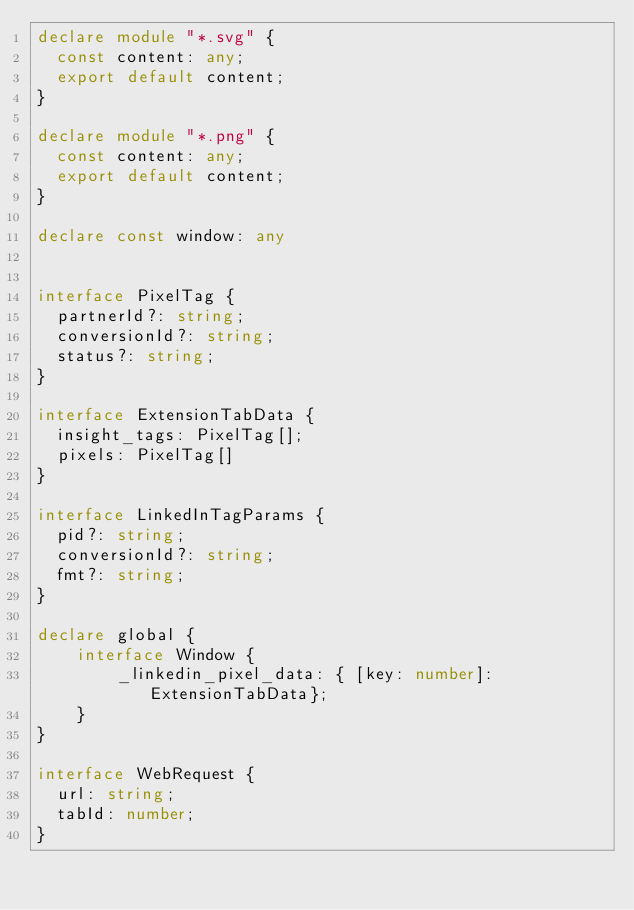<code> <loc_0><loc_0><loc_500><loc_500><_TypeScript_>declare module "*.svg" {
  const content: any;
  export default content;
}

declare module "*.png" {
  const content: any;
  export default content;
}

declare const window: any


interface PixelTag {
  partnerId?: string;
  conversionId?: string;
  status?: string;
}

interface ExtensionTabData {
  insight_tags: PixelTag[];
  pixels: PixelTag[]
}

interface LinkedInTagParams {
  pid?: string;
  conversionId?: string;
  fmt?: string;
}

declare global {
    interface Window {
        _linkedin_pixel_data: { [key: number]: ExtensionTabData};
    }
}

interface WebRequest {
  url: string;
  tabId: number;
}
</code> 